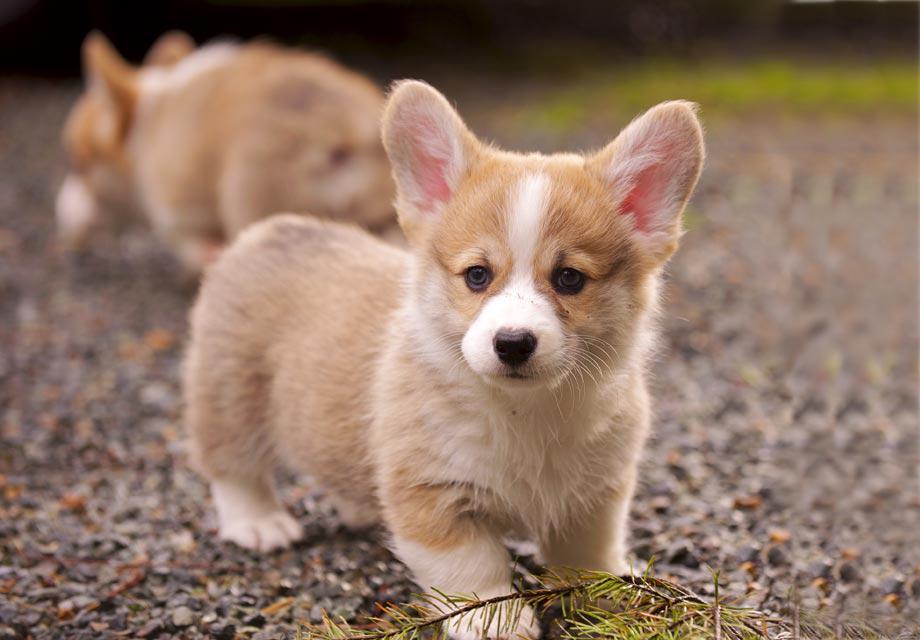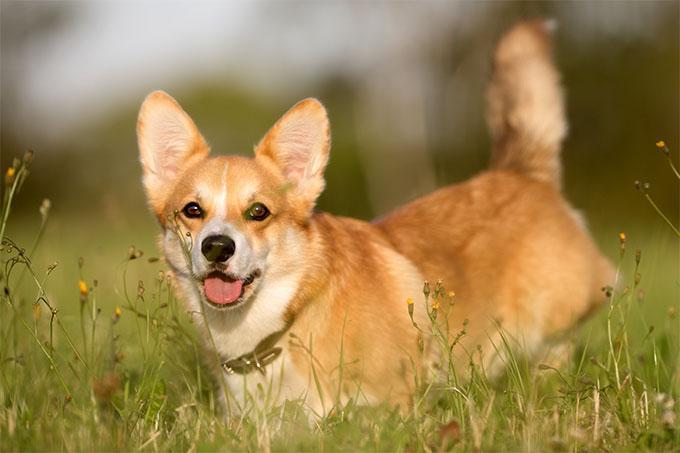The first image is the image on the left, the second image is the image on the right. Considering the images on both sides, is "The dog in the image on the right is on grass." valid? Answer yes or no. Yes. The first image is the image on the left, the second image is the image on the right. Evaluate the accuracy of this statement regarding the images: "One of the dogs is wearing a collar with no charms.". Is it true? Answer yes or no. Yes. 